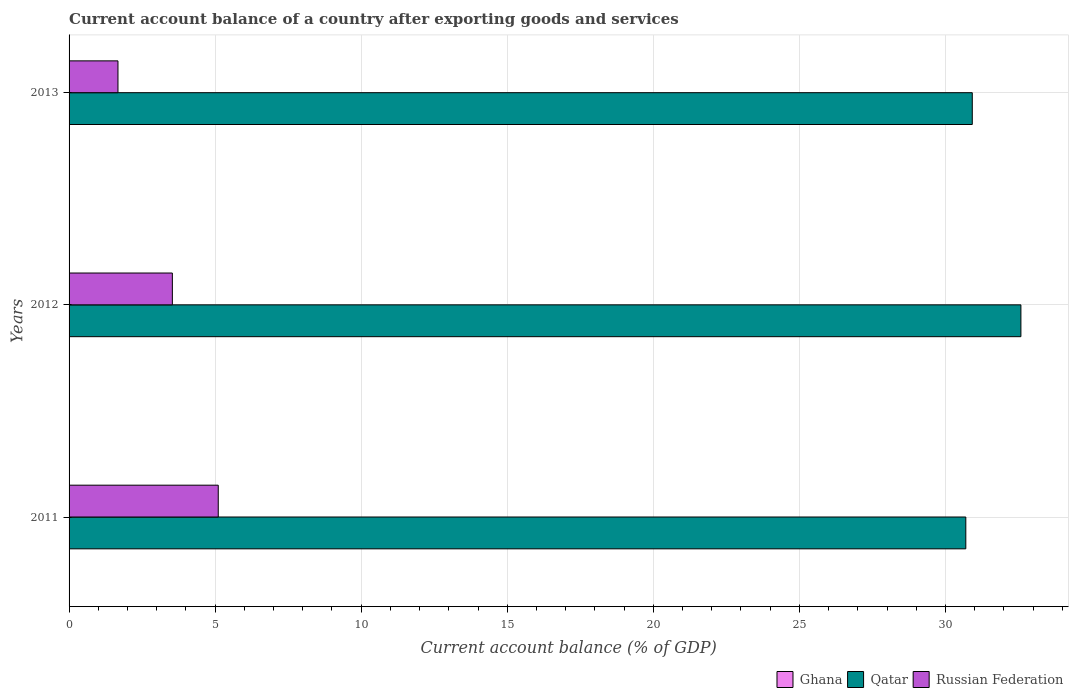How many different coloured bars are there?
Ensure brevity in your answer.  2. How many groups of bars are there?
Keep it short and to the point. 3. Are the number of bars per tick equal to the number of legend labels?
Your answer should be very brief. No. Are the number of bars on each tick of the Y-axis equal?
Offer a terse response. Yes. How many bars are there on the 1st tick from the bottom?
Offer a terse response. 2. What is the label of the 3rd group of bars from the top?
Ensure brevity in your answer.  2011. What is the account balance in Russian Federation in 2013?
Offer a very short reply. 1.67. Across all years, what is the maximum account balance in Russian Federation?
Ensure brevity in your answer.  5.11. Across all years, what is the minimum account balance in Qatar?
Your response must be concise. 30.7. In which year was the account balance in Russian Federation maximum?
Give a very brief answer. 2011. What is the total account balance in Ghana in the graph?
Keep it short and to the point. 0. What is the difference between the account balance in Qatar in 2011 and that in 2013?
Your response must be concise. -0.22. What is the difference between the account balance in Qatar in 2011 and the account balance in Ghana in 2013?
Give a very brief answer. 30.7. In the year 2011, what is the difference between the account balance in Russian Federation and account balance in Qatar?
Offer a very short reply. -25.59. What is the ratio of the account balance in Russian Federation in 2011 to that in 2012?
Offer a terse response. 1.44. What is the difference between the highest and the second highest account balance in Qatar?
Make the answer very short. 1.66. What is the difference between the highest and the lowest account balance in Russian Federation?
Provide a succinct answer. 3.43. In how many years, is the account balance in Russian Federation greater than the average account balance in Russian Federation taken over all years?
Make the answer very short. 2. Is the sum of the account balance in Qatar in 2011 and 2013 greater than the maximum account balance in Russian Federation across all years?
Offer a very short reply. Yes. Is it the case that in every year, the sum of the account balance in Russian Federation and account balance in Qatar is greater than the account balance in Ghana?
Keep it short and to the point. Yes. How many years are there in the graph?
Keep it short and to the point. 3. What is the difference between two consecutive major ticks on the X-axis?
Your response must be concise. 5. Are the values on the major ticks of X-axis written in scientific E-notation?
Provide a short and direct response. No. Does the graph contain grids?
Your answer should be compact. Yes. Where does the legend appear in the graph?
Provide a succinct answer. Bottom right. How many legend labels are there?
Give a very brief answer. 3. How are the legend labels stacked?
Make the answer very short. Horizontal. What is the title of the graph?
Provide a short and direct response. Current account balance of a country after exporting goods and services. Does "High income: nonOECD" appear as one of the legend labels in the graph?
Keep it short and to the point. No. What is the label or title of the X-axis?
Your answer should be compact. Current account balance (% of GDP). What is the label or title of the Y-axis?
Your answer should be very brief. Years. What is the Current account balance (% of GDP) of Qatar in 2011?
Your response must be concise. 30.7. What is the Current account balance (% of GDP) in Russian Federation in 2011?
Ensure brevity in your answer.  5.11. What is the Current account balance (% of GDP) of Ghana in 2012?
Offer a terse response. 0. What is the Current account balance (% of GDP) of Qatar in 2012?
Provide a short and direct response. 32.58. What is the Current account balance (% of GDP) in Russian Federation in 2012?
Make the answer very short. 3.54. What is the Current account balance (% of GDP) in Ghana in 2013?
Provide a short and direct response. 0. What is the Current account balance (% of GDP) in Qatar in 2013?
Give a very brief answer. 30.92. What is the Current account balance (% of GDP) in Russian Federation in 2013?
Your response must be concise. 1.67. Across all years, what is the maximum Current account balance (% of GDP) of Qatar?
Offer a terse response. 32.58. Across all years, what is the maximum Current account balance (% of GDP) of Russian Federation?
Your answer should be very brief. 5.11. Across all years, what is the minimum Current account balance (% of GDP) of Qatar?
Ensure brevity in your answer.  30.7. Across all years, what is the minimum Current account balance (% of GDP) of Russian Federation?
Ensure brevity in your answer.  1.67. What is the total Current account balance (% of GDP) of Qatar in the graph?
Give a very brief answer. 94.2. What is the total Current account balance (% of GDP) of Russian Federation in the graph?
Your answer should be compact. 10.32. What is the difference between the Current account balance (% of GDP) in Qatar in 2011 and that in 2012?
Offer a very short reply. -1.89. What is the difference between the Current account balance (% of GDP) in Russian Federation in 2011 and that in 2012?
Offer a very short reply. 1.57. What is the difference between the Current account balance (% of GDP) in Qatar in 2011 and that in 2013?
Offer a terse response. -0.22. What is the difference between the Current account balance (% of GDP) in Russian Federation in 2011 and that in 2013?
Offer a terse response. 3.43. What is the difference between the Current account balance (% of GDP) in Qatar in 2012 and that in 2013?
Your response must be concise. 1.66. What is the difference between the Current account balance (% of GDP) in Russian Federation in 2012 and that in 2013?
Keep it short and to the point. 1.86. What is the difference between the Current account balance (% of GDP) of Qatar in 2011 and the Current account balance (% of GDP) of Russian Federation in 2012?
Offer a very short reply. 27.16. What is the difference between the Current account balance (% of GDP) in Qatar in 2011 and the Current account balance (% of GDP) in Russian Federation in 2013?
Offer a terse response. 29.02. What is the difference between the Current account balance (% of GDP) in Qatar in 2012 and the Current account balance (% of GDP) in Russian Federation in 2013?
Ensure brevity in your answer.  30.91. What is the average Current account balance (% of GDP) in Ghana per year?
Provide a short and direct response. 0. What is the average Current account balance (% of GDP) in Qatar per year?
Your answer should be very brief. 31.4. What is the average Current account balance (% of GDP) of Russian Federation per year?
Offer a terse response. 3.44. In the year 2011, what is the difference between the Current account balance (% of GDP) of Qatar and Current account balance (% of GDP) of Russian Federation?
Your answer should be compact. 25.59. In the year 2012, what is the difference between the Current account balance (% of GDP) in Qatar and Current account balance (% of GDP) in Russian Federation?
Offer a very short reply. 29.05. In the year 2013, what is the difference between the Current account balance (% of GDP) in Qatar and Current account balance (% of GDP) in Russian Federation?
Keep it short and to the point. 29.24. What is the ratio of the Current account balance (% of GDP) in Qatar in 2011 to that in 2012?
Your answer should be compact. 0.94. What is the ratio of the Current account balance (% of GDP) of Russian Federation in 2011 to that in 2012?
Give a very brief answer. 1.44. What is the ratio of the Current account balance (% of GDP) in Qatar in 2011 to that in 2013?
Keep it short and to the point. 0.99. What is the ratio of the Current account balance (% of GDP) in Russian Federation in 2011 to that in 2013?
Your response must be concise. 3.05. What is the ratio of the Current account balance (% of GDP) in Qatar in 2012 to that in 2013?
Ensure brevity in your answer.  1.05. What is the ratio of the Current account balance (% of GDP) of Russian Federation in 2012 to that in 2013?
Give a very brief answer. 2.11. What is the difference between the highest and the second highest Current account balance (% of GDP) in Qatar?
Your response must be concise. 1.66. What is the difference between the highest and the second highest Current account balance (% of GDP) in Russian Federation?
Give a very brief answer. 1.57. What is the difference between the highest and the lowest Current account balance (% of GDP) of Qatar?
Your answer should be very brief. 1.89. What is the difference between the highest and the lowest Current account balance (% of GDP) of Russian Federation?
Provide a succinct answer. 3.43. 